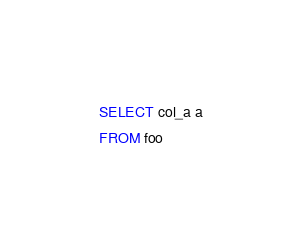Convert code to text. <code><loc_0><loc_0><loc_500><loc_500><_SQL_>SELECT col_a a
FROM foo
</code> 